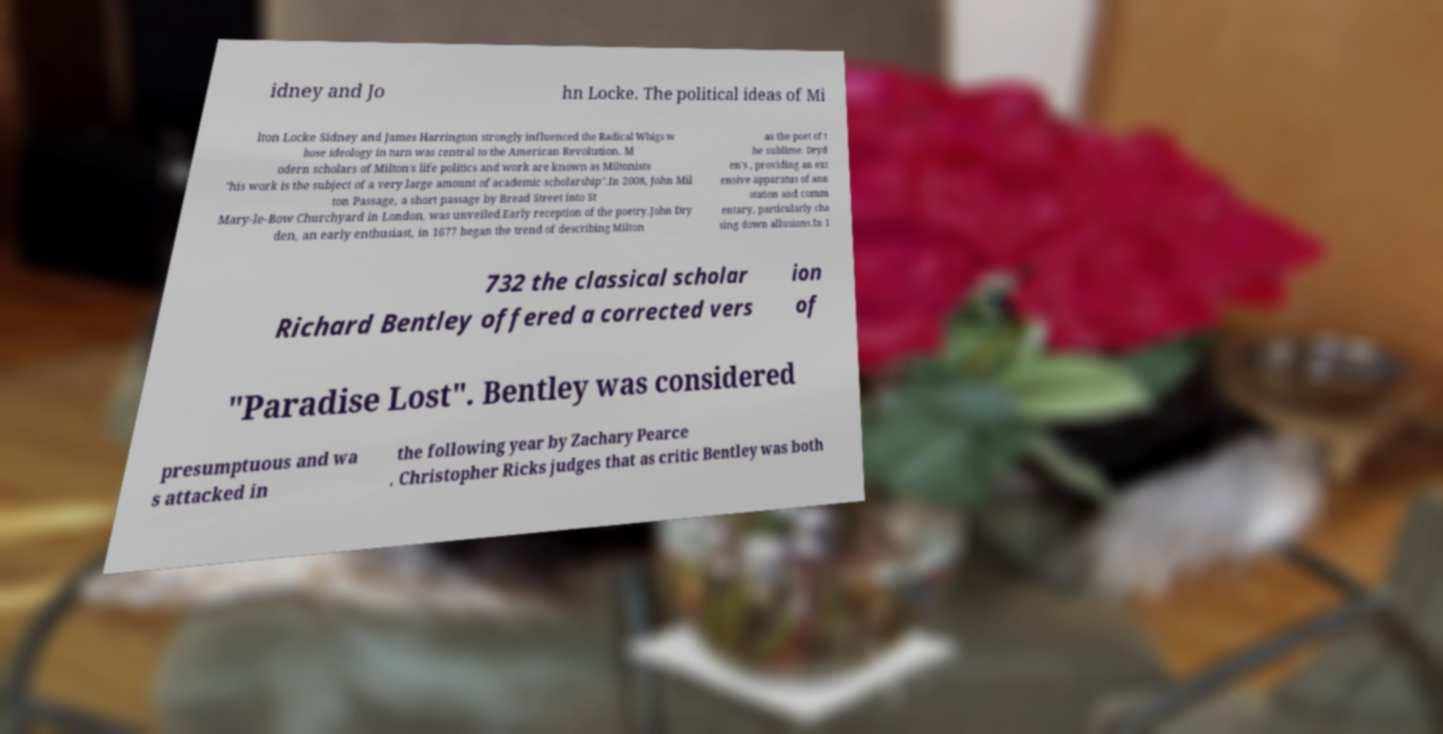I need the written content from this picture converted into text. Can you do that? idney and Jo hn Locke. The political ideas of Mi lton Locke Sidney and James Harrington strongly influenced the Radical Whigs w hose ideology in turn was central to the American Revolution. M odern scholars of Milton's life politics and work are known as Miltonists "his work is the subject of a very large amount of academic scholarship".In 2008, John Mil ton Passage, a short passage by Bread Street into St Mary-le-Bow Churchyard in London, was unveiled.Early reception of the poetry.John Dry den, an early enthusiast, in 1677 began the trend of describing Milton as the poet of t he sublime. Dryd en's , providing an ext ensive apparatus of ann otation and comm entary, particularly cha sing down allusions.In 1 732 the classical scholar Richard Bentley offered a corrected vers ion of "Paradise Lost". Bentley was considered presumptuous and wa s attacked in the following year by Zachary Pearce . Christopher Ricks judges that as critic Bentley was both 